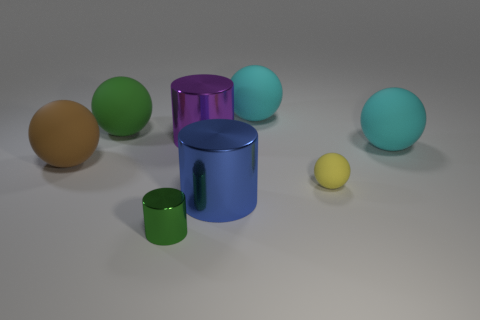Subtract all green balls. How many balls are left? 4 Subtract all brown balls. How many balls are left? 4 Subtract all red spheres. Subtract all red cubes. How many spheres are left? 5 Add 1 yellow matte spheres. How many objects exist? 9 Subtract all cylinders. How many objects are left? 5 Subtract all large blue cylinders. Subtract all large blue metallic cylinders. How many objects are left? 6 Add 4 large cyan rubber balls. How many large cyan rubber balls are left? 6 Add 7 small green shiny objects. How many small green shiny objects exist? 8 Subtract 0 gray spheres. How many objects are left? 8 